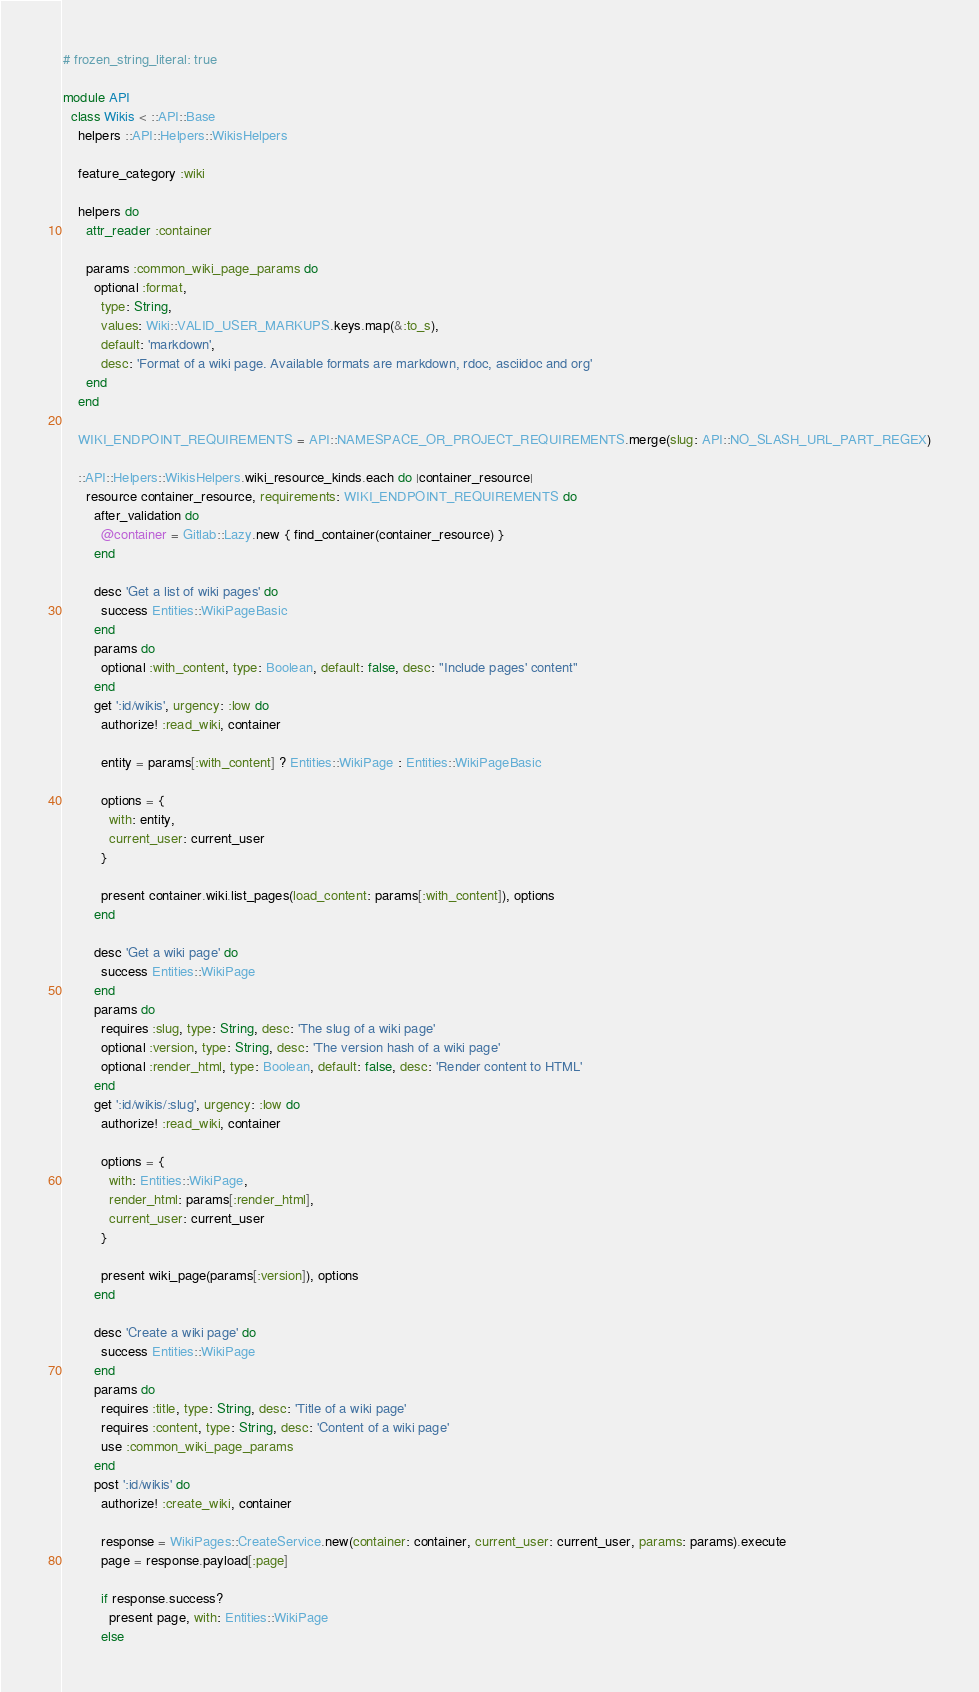Convert code to text. <code><loc_0><loc_0><loc_500><loc_500><_Ruby_># frozen_string_literal: true

module API
  class Wikis < ::API::Base
    helpers ::API::Helpers::WikisHelpers

    feature_category :wiki

    helpers do
      attr_reader :container

      params :common_wiki_page_params do
        optional :format,
          type: String,
          values: Wiki::VALID_USER_MARKUPS.keys.map(&:to_s),
          default: 'markdown',
          desc: 'Format of a wiki page. Available formats are markdown, rdoc, asciidoc and org'
      end
    end

    WIKI_ENDPOINT_REQUIREMENTS = API::NAMESPACE_OR_PROJECT_REQUIREMENTS.merge(slug: API::NO_SLASH_URL_PART_REGEX)

    ::API::Helpers::WikisHelpers.wiki_resource_kinds.each do |container_resource|
      resource container_resource, requirements: WIKI_ENDPOINT_REQUIREMENTS do
        after_validation do
          @container = Gitlab::Lazy.new { find_container(container_resource) }
        end

        desc 'Get a list of wiki pages' do
          success Entities::WikiPageBasic
        end
        params do
          optional :with_content, type: Boolean, default: false, desc: "Include pages' content"
        end
        get ':id/wikis', urgency: :low do
          authorize! :read_wiki, container

          entity = params[:with_content] ? Entities::WikiPage : Entities::WikiPageBasic

          options = {
            with: entity,
            current_user: current_user
          }

          present container.wiki.list_pages(load_content: params[:with_content]), options
        end

        desc 'Get a wiki page' do
          success Entities::WikiPage
        end
        params do
          requires :slug, type: String, desc: 'The slug of a wiki page'
          optional :version, type: String, desc: 'The version hash of a wiki page'
          optional :render_html, type: Boolean, default: false, desc: 'Render content to HTML'
        end
        get ':id/wikis/:slug', urgency: :low do
          authorize! :read_wiki, container

          options = {
            with: Entities::WikiPage,
            render_html: params[:render_html],
            current_user: current_user
          }

          present wiki_page(params[:version]), options
        end

        desc 'Create a wiki page' do
          success Entities::WikiPage
        end
        params do
          requires :title, type: String, desc: 'Title of a wiki page'
          requires :content, type: String, desc: 'Content of a wiki page'
          use :common_wiki_page_params
        end
        post ':id/wikis' do
          authorize! :create_wiki, container

          response = WikiPages::CreateService.new(container: container, current_user: current_user, params: params).execute
          page = response.payload[:page]

          if response.success?
            present page, with: Entities::WikiPage
          else</code> 